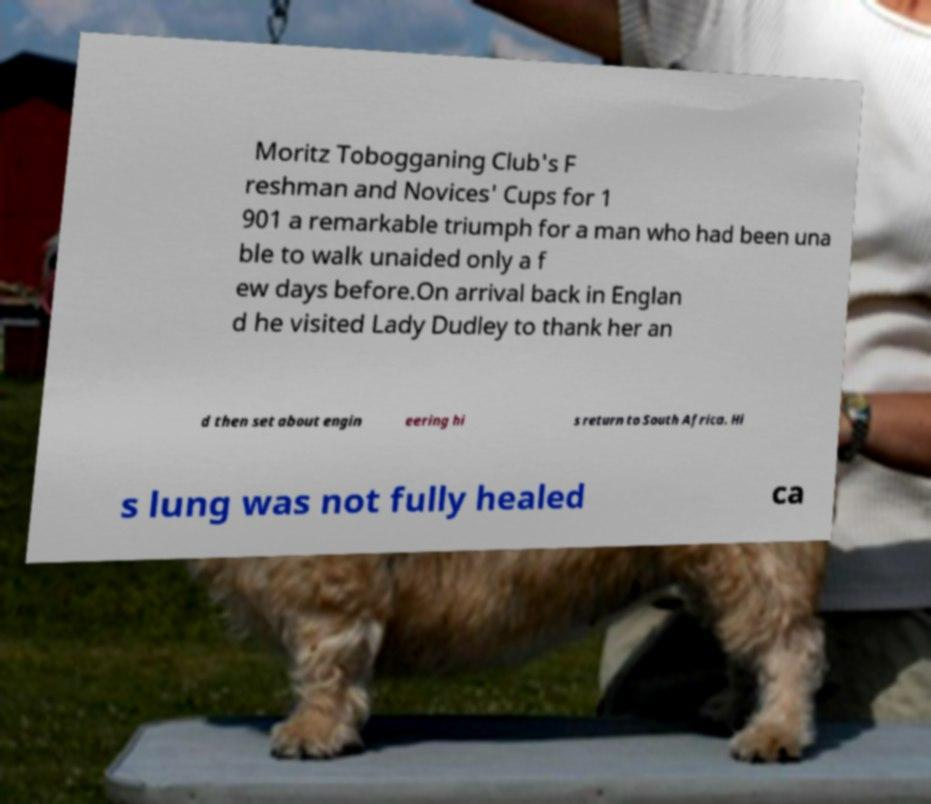For documentation purposes, I need the text within this image transcribed. Could you provide that? Moritz Tobogganing Club's F reshman and Novices' Cups for 1 901 a remarkable triumph for a man who had been una ble to walk unaided only a f ew days before.On arrival back in Englan d he visited Lady Dudley to thank her an d then set about engin eering hi s return to South Africa. Hi s lung was not fully healed ca 